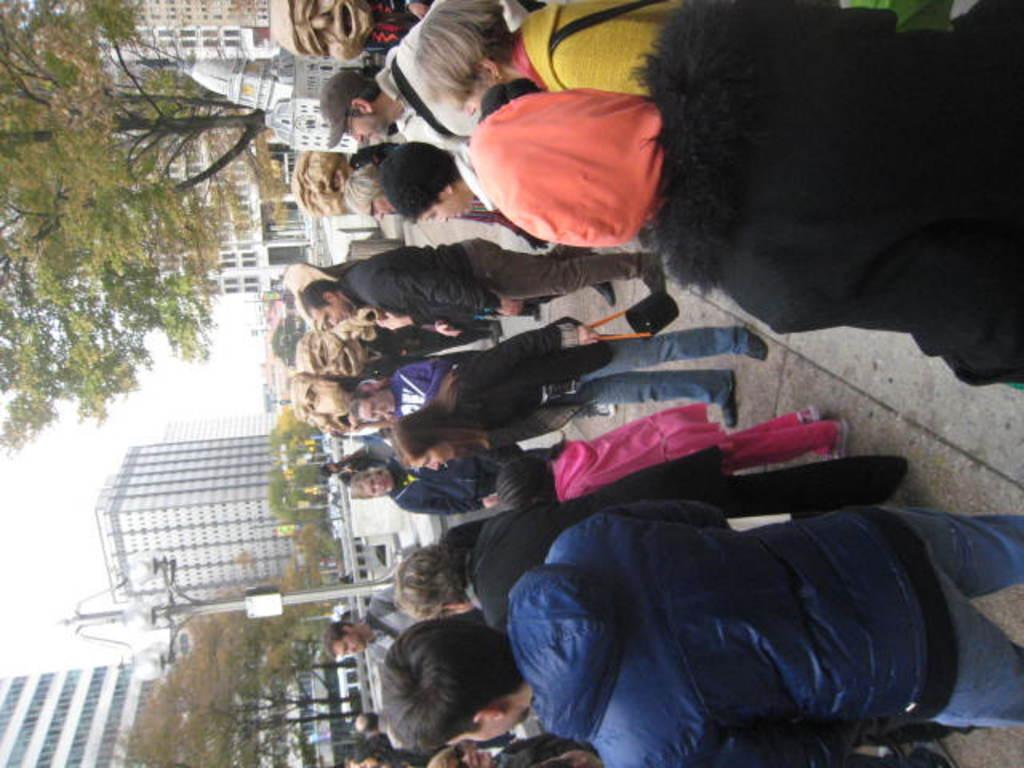What is happening in the street in the image? There are many people standing in the street in the image. What can be seen in the background of the image? There are buildings in the background of the image. What type of vegetation is present in front of the buildings? Trees are present in front of the buildings in the image. How is the image oriented? The image appears to be rotated. What type of peace symbol can be seen on the prison in the image? There is no peace symbol or prison present in the image. How did the earthquake affect the buildings in the image? There is no indication of an earthquake or any damage to the buildings in the image. 